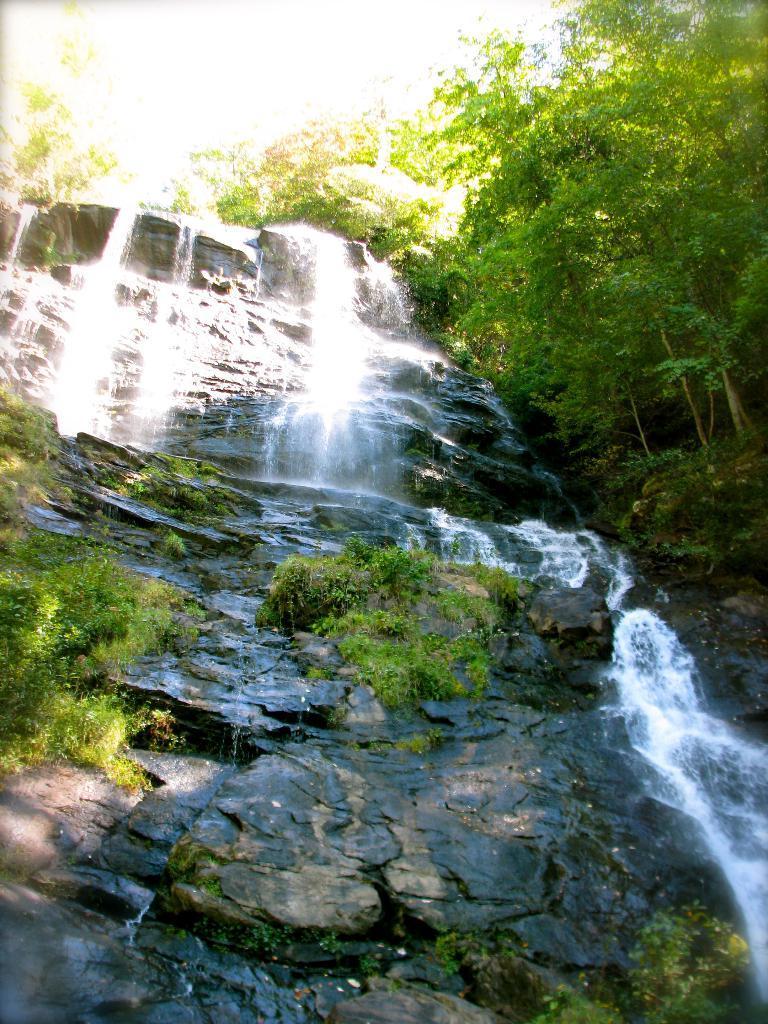Could you give a brief overview of what you see in this image? In this image in the center there is a waterfall, and there are some plants, rocks and trees. 